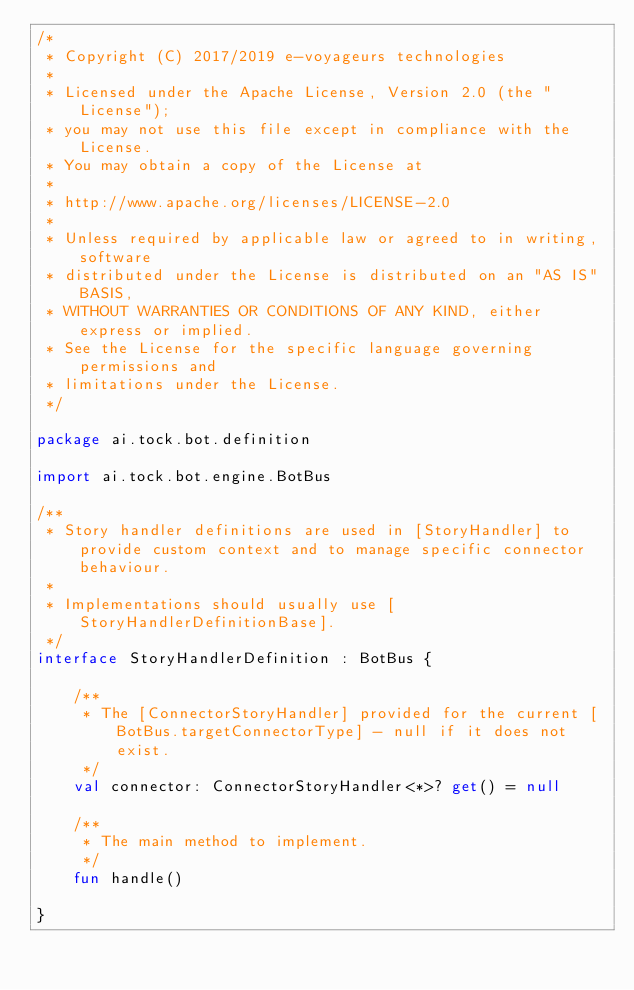Convert code to text. <code><loc_0><loc_0><loc_500><loc_500><_Kotlin_>/*
 * Copyright (C) 2017/2019 e-voyageurs technologies
 *
 * Licensed under the Apache License, Version 2.0 (the "License");
 * you may not use this file except in compliance with the License.
 * You may obtain a copy of the License at
 *
 * http://www.apache.org/licenses/LICENSE-2.0
 *
 * Unless required by applicable law or agreed to in writing, software
 * distributed under the License is distributed on an "AS IS" BASIS,
 * WITHOUT WARRANTIES OR CONDITIONS OF ANY KIND, either express or implied.
 * See the License for the specific language governing permissions and
 * limitations under the License.
 */

package ai.tock.bot.definition

import ai.tock.bot.engine.BotBus

/**
 * Story handler definitions are used in [StoryHandler] to provide custom context and to manage specific connector behaviour.
 *
 * Implementations should usually use [StoryHandlerDefinitionBase].
 */
interface StoryHandlerDefinition : BotBus {

    /**
     * The [ConnectorStoryHandler] provided for the current [BotBus.targetConnectorType] - null if it does not exist.
     */
    val connector: ConnectorStoryHandler<*>? get() = null

    /**
     * The main method to implement.
     */
    fun handle()

}</code> 